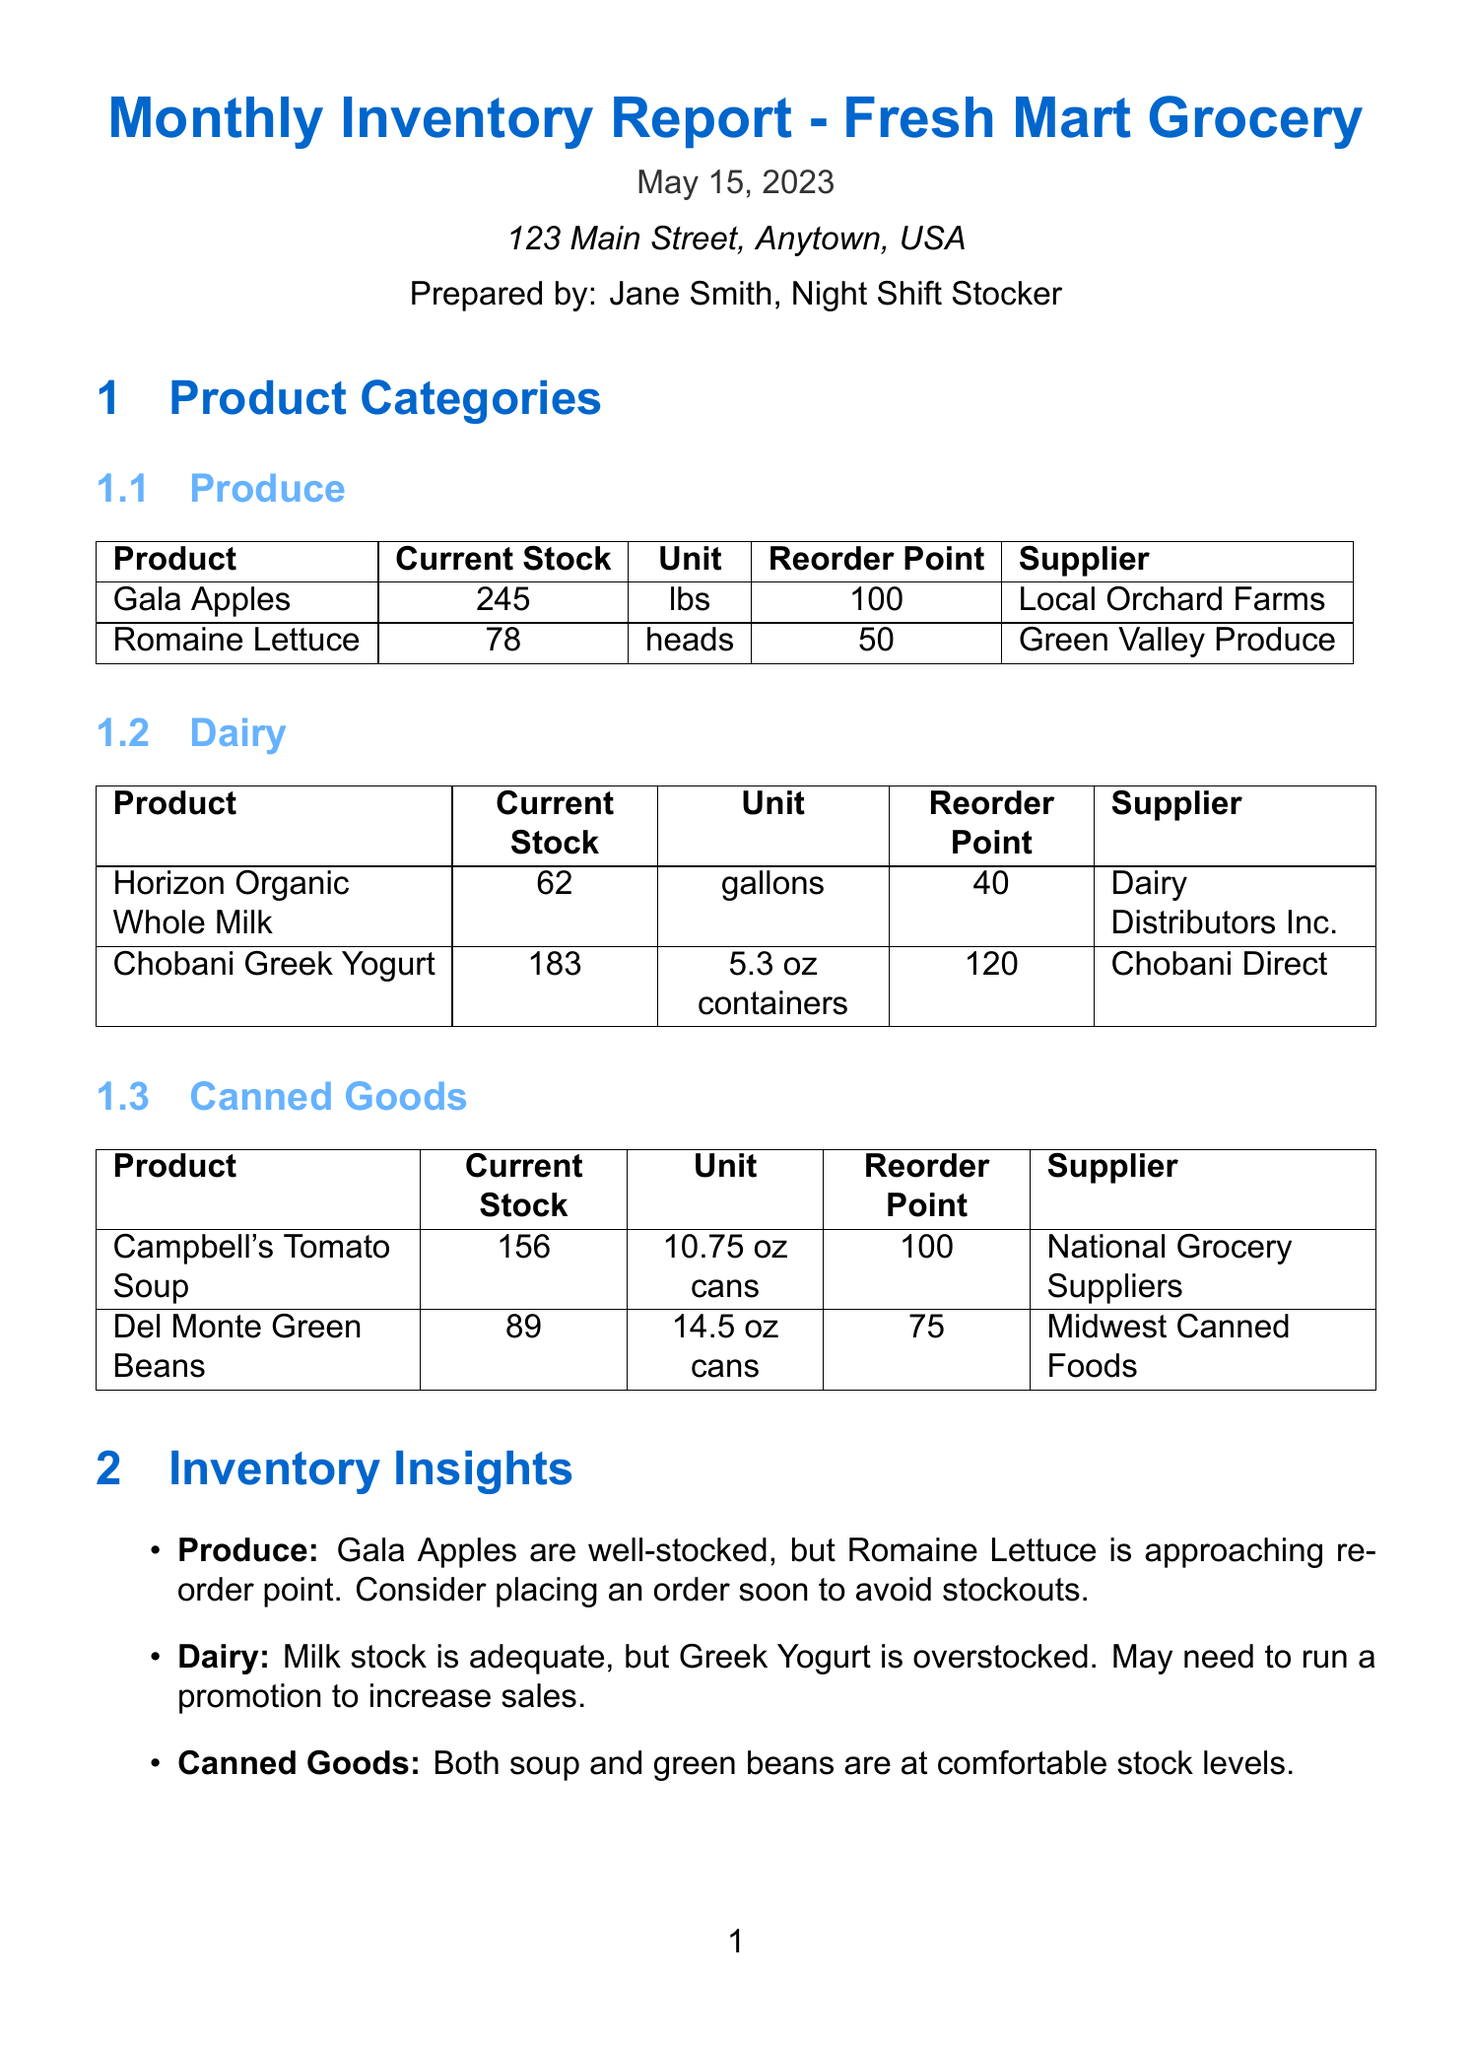What is the title of the report? The title is stated prominently at the beginning of the document.
Answer: Monthly Inventory Report - Fresh Mart Grocery Who prepared the report? The name of the person who prepared the report is mentioned in the document.
Answer: Jane Smith, Night Shift Stocker What is the reorder point for Romaine Lettuce? The reorder point can be found in the product categories section specifically for Romaine Lettuce.
Answer: 50 Which product category has the current stock of 89 units? By examining the product categories, we can identify which item corresponds to this stock level.
Answer: Canned Goods What action item is associated with the Dairy category? The document includes specific action items related to each product category.
Answer: Monitor expiration dates closely and place yogurt on end-cap display What is the expected date range for the upcoming Memorial Day Weekend event? The document provides a specific date range for the noted upcoming event.
Answer: May 27-29, 2023 Which supplier is listed for Gala Apples? The supplier for each item is specified in the product categories section.
Answer: Local Orchard Farms What observation is made about Greek Yogurt stock? The observation provides insight into the stock status of Greek Yogurt.
Answer: Greek Yogurt is overstocked What efficiency improvement was implemented in the produce section? The document lists specific improvements made in the store layout for efficiency.
Answer: Implemented new shelf labeling system in produce section 